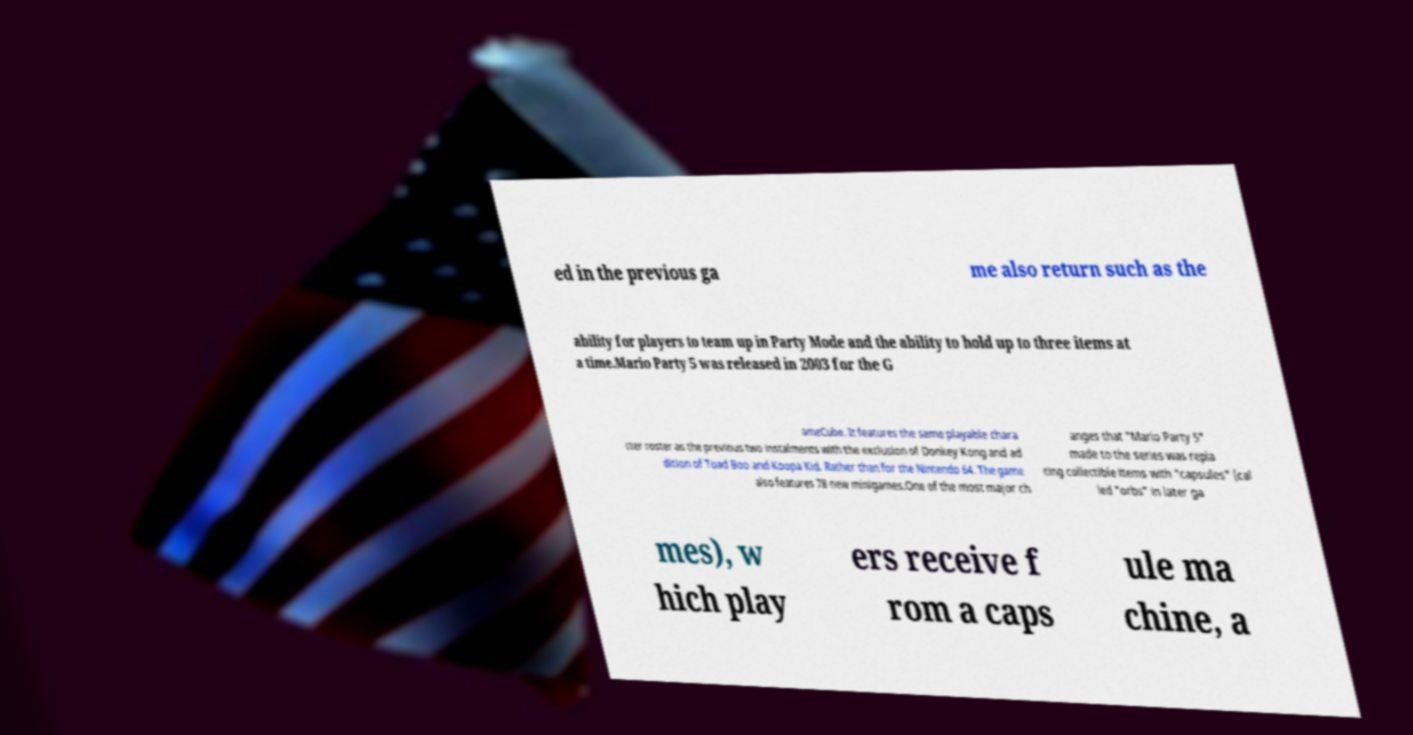Can you read and provide the text displayed in the image?This photo seems to have some interesting text. Can you extract and type it out for me? ed in the previous ga me also return such as the ability for players to team up in Party Mode and the ability to hold up to three items at a time.Mario Party 5 was released in 2003 for the G ameCube. It features the same playable chara cter roster as the previous two instalments with the exclusion of Donkey Kong and ad dition of Toad Boo and Koopa Kid. Rather than for the Nintendo 64. The game also features 78 new minigames.One of the most major ch anges that "Mario Party 5" made to the series was repla cing collectible items with "capsules" (cal led "orbs" in later ga mes), w hich play ers receive f rom a caps ule ma chine, a 